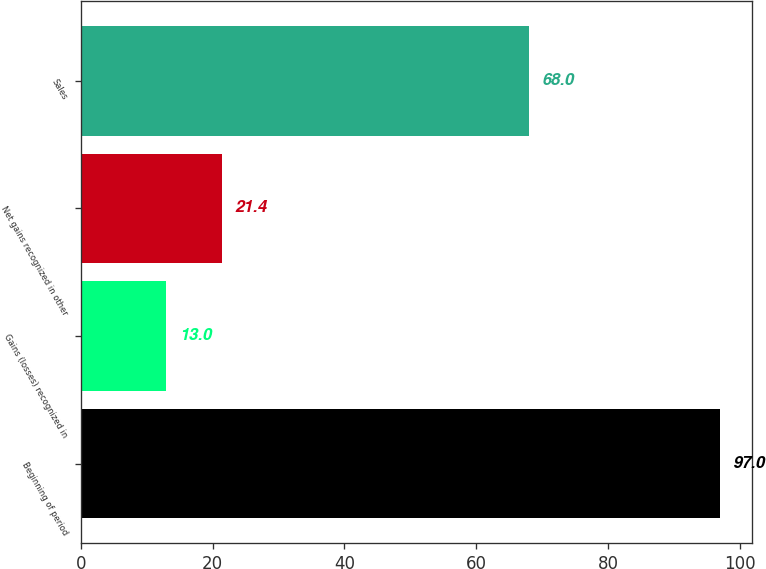<chart> <loc_0><loc_0><loc_500><loc_500><bar_chart><fcel>Beginning of period<fcel>Gains (losses) recognized in<fcel>Net gains recognized in other<fcel>Sales<nl><fcel>97<fcel>13<fcel>21.4<fcel>68<nl></chart> 